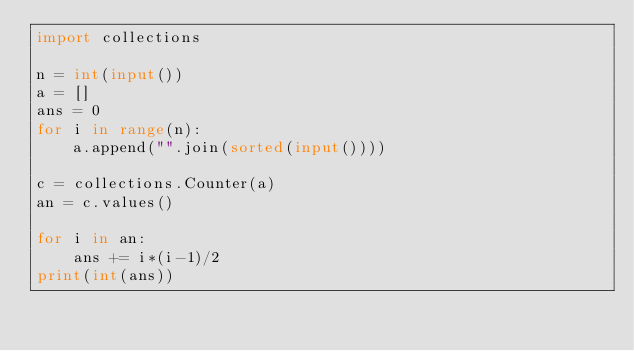Convert code to text. <code><loc_0><loc_0><loc_500><loc_500><_Python_>import collections

n = int(input())
a = []
ans = 0
for i in range(n):
    a.append("".join(sorted(input())))

c = collections.Counter(a)
an = c.values()

for i in an:
    ans += i*(i-1)/2
print(int(ans))</code> 